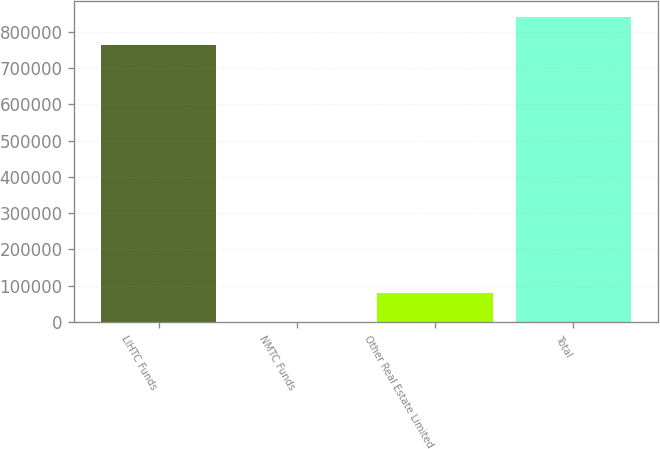Convert chart. <chart><loc_0><loc_0><loc_500><loc_500><bar_chart><fcel>LIHTC Funds<fcel>NMTC Funds<fcel>Other Real Estate Limited<fcel>Total<nl><fcel>762346<fcel>278<fcel>80063.8<fcel>842132<nl></chart> 